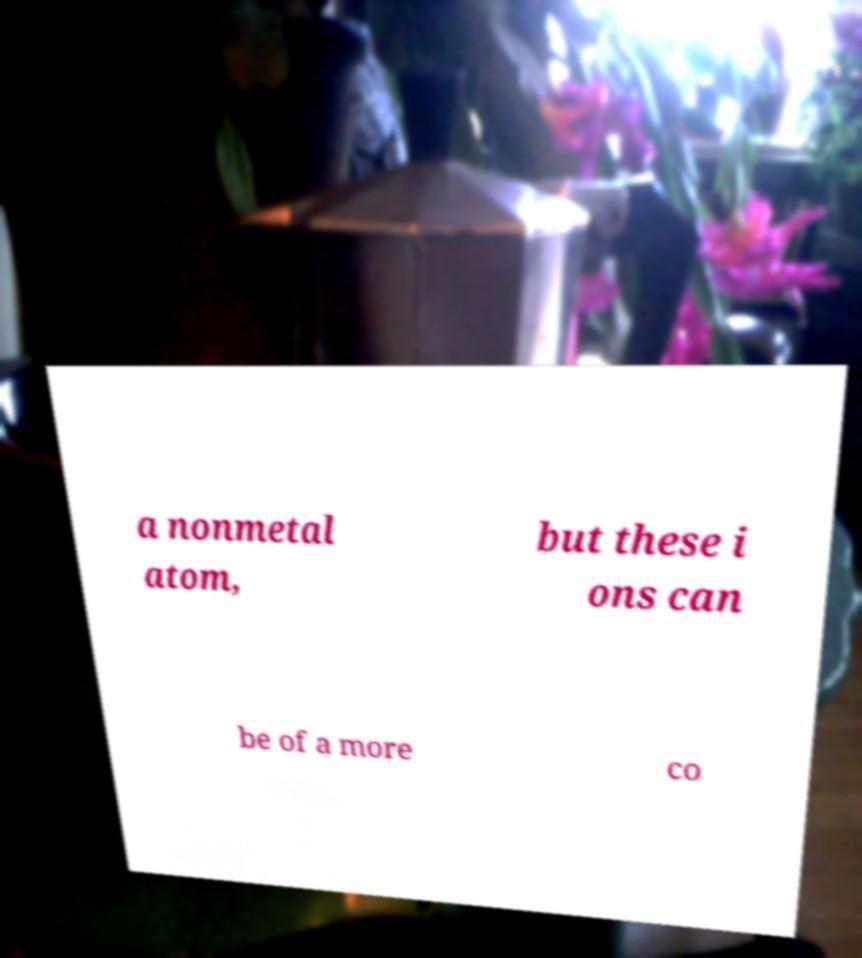Please read and relay the text visible in this image. What does it say? a nonmetal atom, but these i ons can be of a more co 